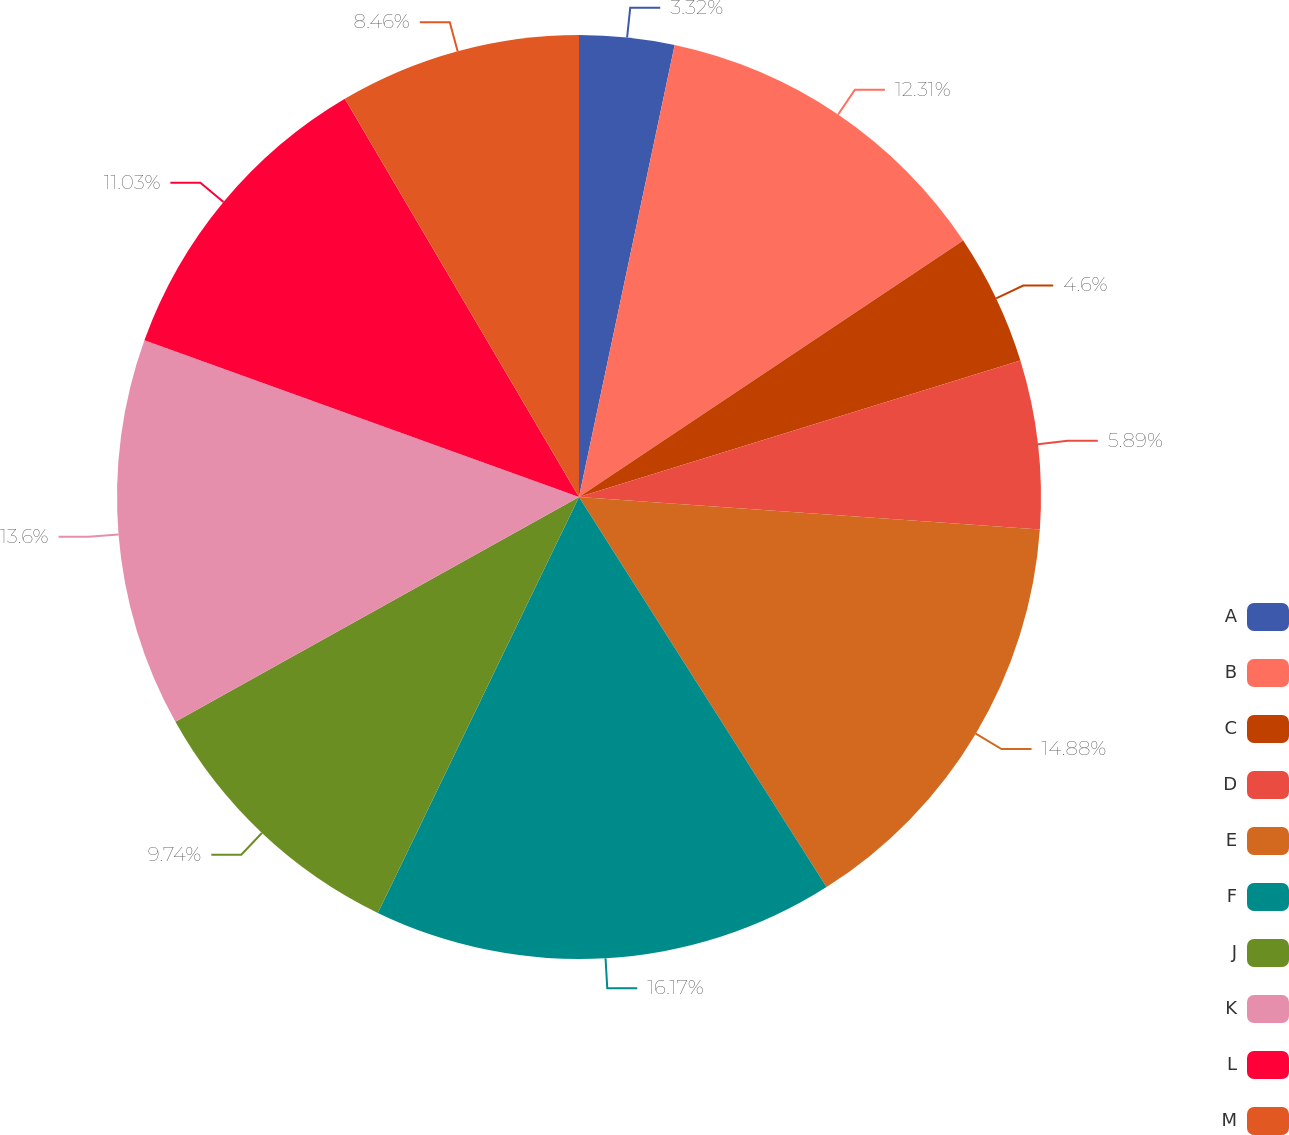Convert chart. <chart><loc_0><loc_0><loc_500><loc_500><pie_chart><fcel>A<fcel>B<fcel>C<fcel>D<fcel>E<fcel>F<fcel>J<fcel>K<fcel>L<fcel>M<nl><fcel>3.32%<fcel>12.31%<fcel>4.6%<fcel>5.89%<fcel>14.88%<fcel>16.17%<fcel>9.74%<fcel>13.6%<fcel>11.03%<fcel>8.46%<nl></chart> 